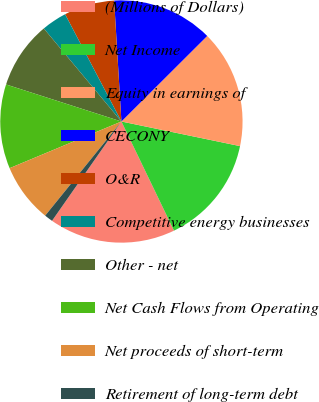<chart> <loc_0><loc_0><loc_500><loc_500><pie_chart><fcel>(Millions of Dollars)<fcel>Net Income<fcel>Equity in earnings of<fcel>CECONY<fcel>O&R<fcel>Competitive energy businesses<fcel>Other - net<fcel>Net Cash Flows from Operating<fcel>Net proceeds of short-term<fcel>Retirement of long-term debt<nl><fcel>16.85%<fcel>14.6%<fcel>15.73%<fcel>13.48%<fcel>6.74%<fcel>3.37%<fcel>8.99%<fcel>11.24%<fcel>7.87%<fcel>1.13%<nl></chart> 